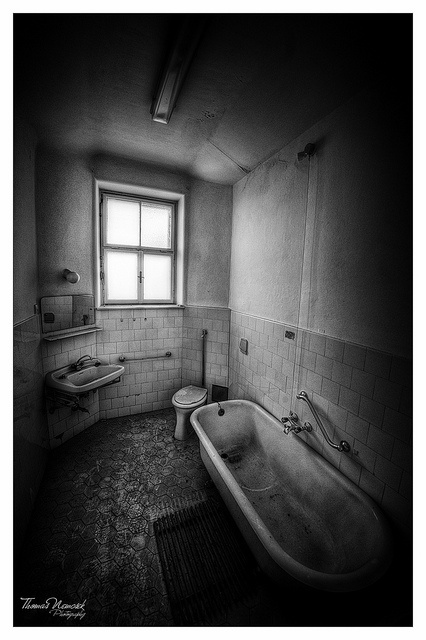Describe the objects in this image and their specific colors. I can see sink in white, gray, black, and lightgray tones and toilet in white, gray, black, and lightgray tones in this image. 